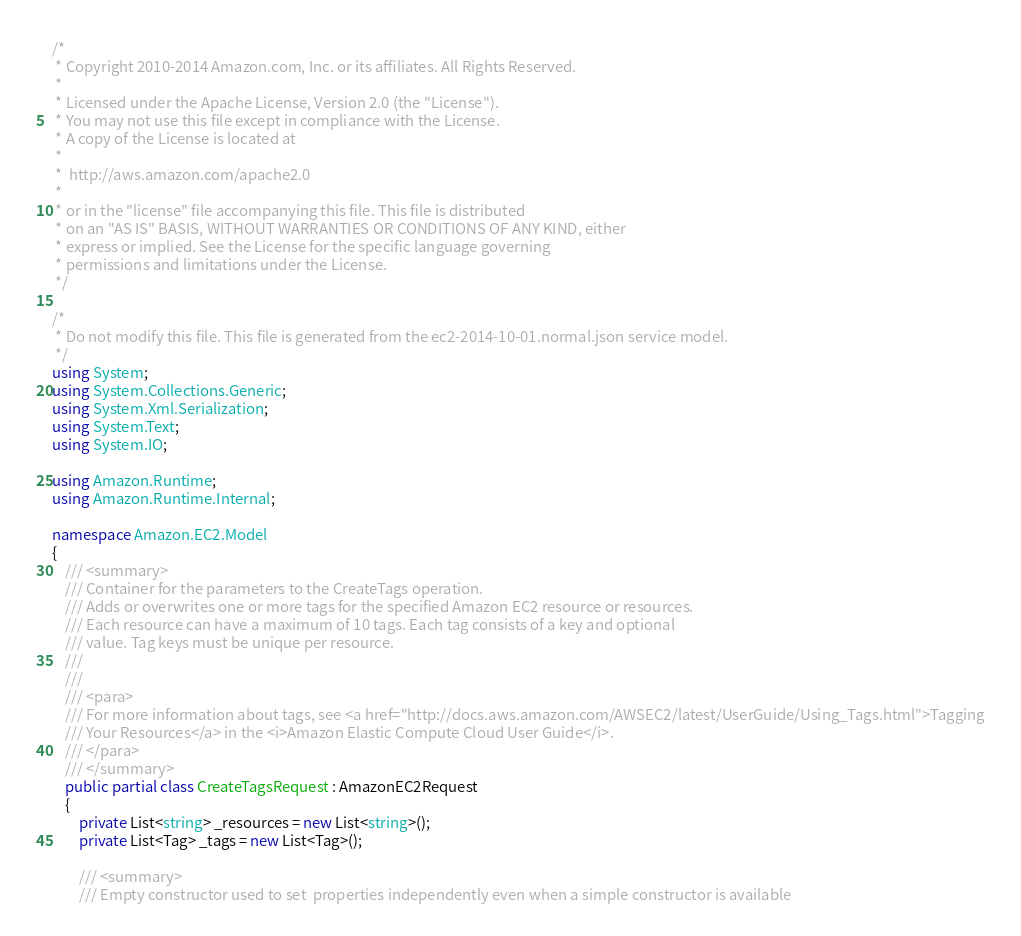<code> <loc_0><loc_0><loc_500><loc_500><_C#_>/*
 * Copyright 2010-2014 Amazon.com, Inc. or its affiliates. All Rights Reserved.
 * 
 * Licensed under the Apache License, Version 2.0 (the "License").
 * You may not use this file except in compliance with the License.
 * A copy of the License is located at
 * 
 *  http://aws.amazon.com/apache2.0
 * 
 * or in the "license" file accompanying this file. This file is distributed
 * on an "AS IS" BASIS, WITHOUT WARRANTIES OR CONDITIONS OF ANY KIND, either
 * express or implied. See the License for the specific language governing
 * permissions and limitations under the License.
 */

/*
 * Do not modify this file. This file is generated from the ec2-2014-10-01.normal.json service model.
 */
using System;
using System.Collections.Generic;
using System.Xml.Serialization;
using System.Text;
using System.IO;

using Amazon.Runtime;
using Amazon.Runtime.Internal;

namespace Amazon.EC2.Model
{
    /// <summary>
    /// Container for the parameters to the CreateTags operation.
    /// Adds or overwrites one or more tags for the specified Amazon EC2 resource or resources.
    /// Each resource can have a maximum of 10 tags. Each tag consists of a key and optional
    /// value. Tag keys must be unique per resource.
    /// 
    ///  
    /// <para>
    /// For more information about tags, see <a href="http://docs.aws.amazon.com/AWSEC2/latest/UserGuide/Using_Tags.html">Tagging
    /// Your Resources</a> in the <i>Amazon Elastic Compute Cloud User Guide</i>.
    /// </para>
    /// </summary>
    public partial class CreateTagsRequest : AmazonEC2Request
    {
        private List<string> _resources = new List<string>();
        private List<Tag> _tags = new List<Tag>();

        /// <summary>
        /// Empty constructor used to set  properties independently even when a simple constructor is available</code> 